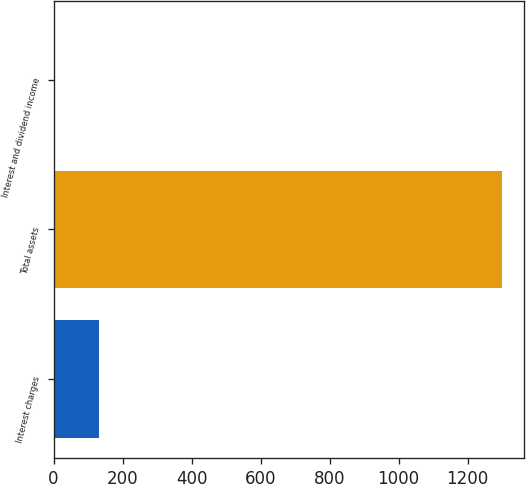<chart> <loc_0><loc_0><loc_500><loc_500><bar_chart><fcel>Interest charges<fcel>Total assets<fcel>Interest and dividend income<nl><fcel>130.9<fcel>1300<fcel>1<nl></chart> 